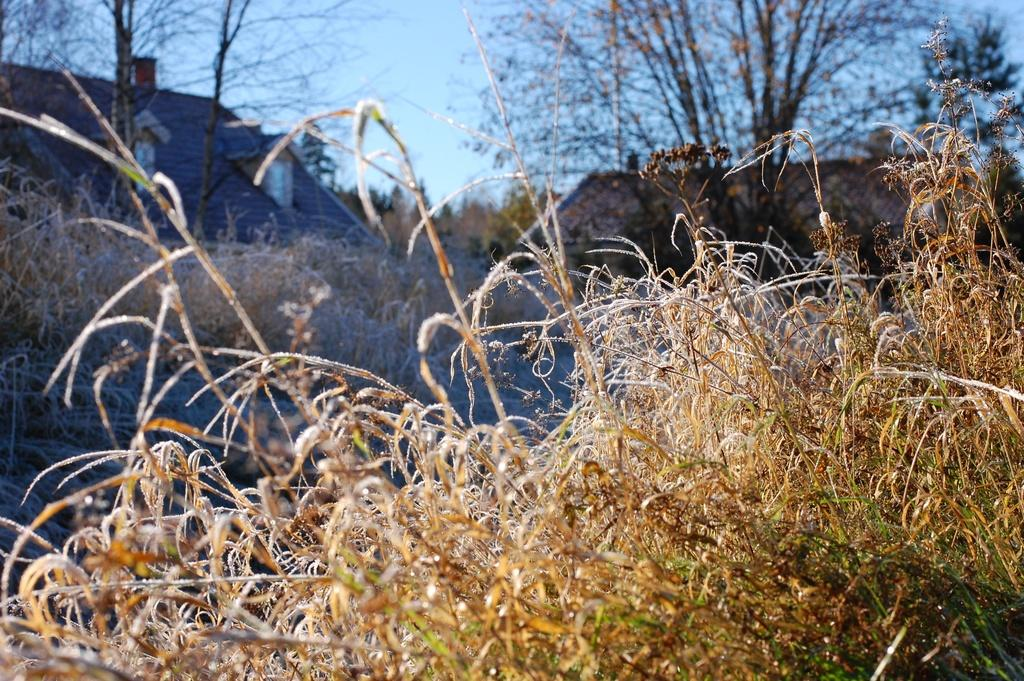What type of vegetation is present in the image? There is grass in the image. What type of structures can be seen in the image? There are houses in the image. What other natural elements are visible in the image? There are trees in the image. What type of bait is used to attract animals in the image? There is no bait present in the image; it features grass, houses, and trees. What type of scent can be detected in the image? There is no mention of any scent in the image; it only features grass, houses, and trees. 